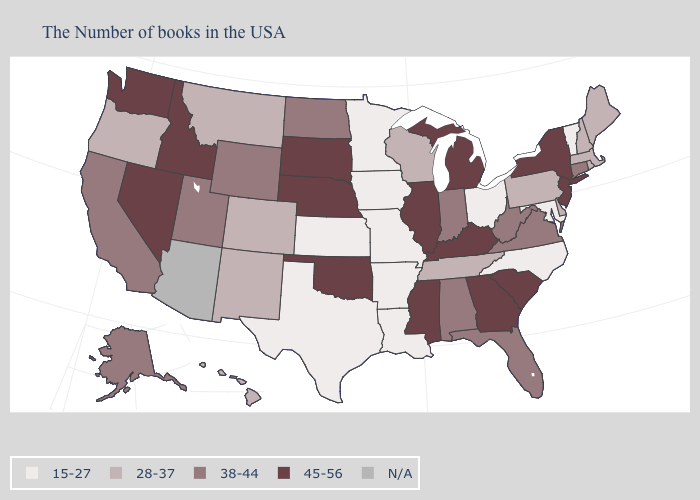What is the value of Wyoming?
Short answer required. 38-44. Does Montana have the highest value in the West?
Write a very short answer. No. Does Iowa have the lowest value in the USA?
Concise answer only. Yes. How many symbols are there in the legend?
Short answer required. 5. Which states have the lowest value in the USA?
Give a very brief answer. Vermont, Maryland, North Carolina, Ohio, Louisiana, Missouri, Arkansas, Minnesota, Iowa, Kansas, Texas. Which states have the lowest value in the MidWest?
Answer briefly. Ohio, Missouri, Minnesota, Iowa, Kansas. Does Arkansas have the lowest value in the USA?
Write a very short answer. Yes. Does South Dakota have the highest value in the USA?
Keep it brief. Yes. What is the value of North Dakota?
Be succinct. 38-44. What is the value of South Carolina?
Keep it brief. 45-56. What is the value of West Virginia?
Keep it brief. 38-44. Does New York have the lowest value in the Northeast?
Write a very short answer. No. What is the value of Delaware?
Quick response, please. 28-37. Does the map have missing data?
Concise answer only. Yes. 